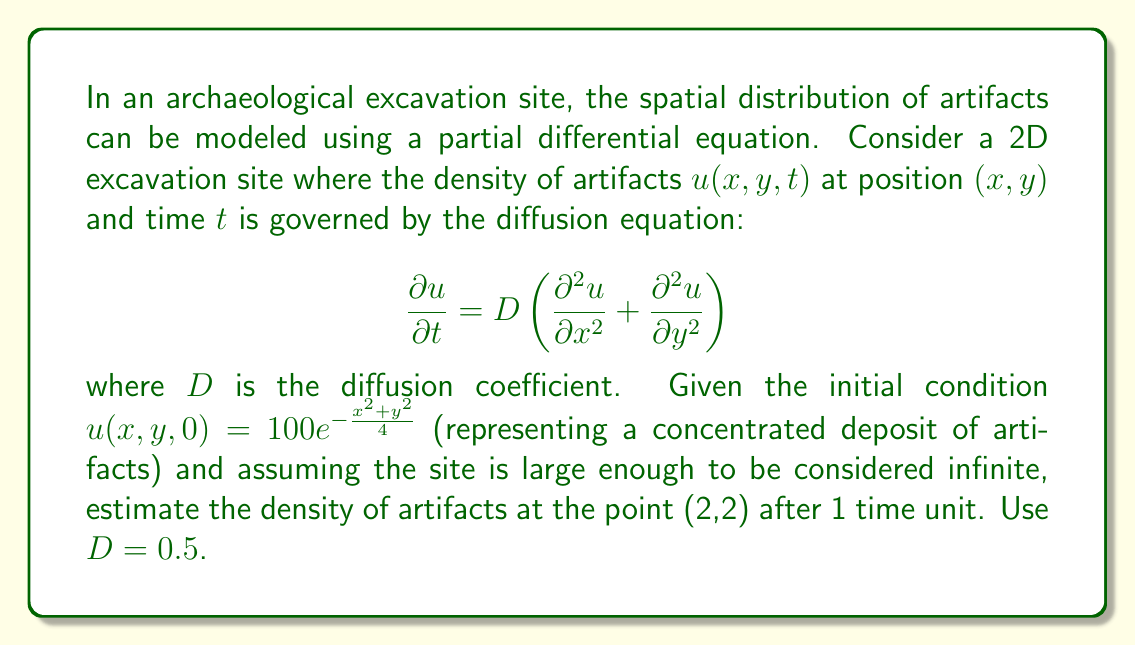Solve this math problem. To solve this problem, we need to use the fundamental solution of the 2D diffusion equation. The solution for an initial point source $\delta(x,y)$ is:

$$u(x,y,t) = \frac{1}{4\pi Dt}e^{-\frac{x^2+y^2}{4Dt}}$$

For our initial condition $u(x,y,0) = 100e^{-\frac{x^2+y^2}{4}}$, we can use the principle of superposition. The solution is the convolution of the initial condition with the fundamental solution:

$$u(x,y,t) = \int_{-\infty}^{\infty}\int_{-\infty}^{\infty} 100e^{-\frac{x'^2+y'^2}{4}} \cdot \frac{1}{4\pi Dt}e^{-\frac{(x-x')^2+(y-y')^2}{4Dt}} dx'dy'$$

This integral can be evaluated analytically, resulting in:

$$u(x,y,t) = \frac{100}{1+t} e^{-\frac{x^2+y^2}{4(1+t)}}$$

Now, we can substitute the given values:
- $x = 2$
- $y = 2$
- $t = 1$
- $D = 0.5$ (note that $D$ doesn't appear in the final formula)

$$u(2,2,1) = \frac{100}{1+1} e^{-\frac{2^2+2^2}{4(1+1)}} = 50e^{-1} \approx 18.39$$
Answer: The estimated density of artifacts at the point (2,2) after 1 time unit is approximately 18.39 artifacts per unit area. 